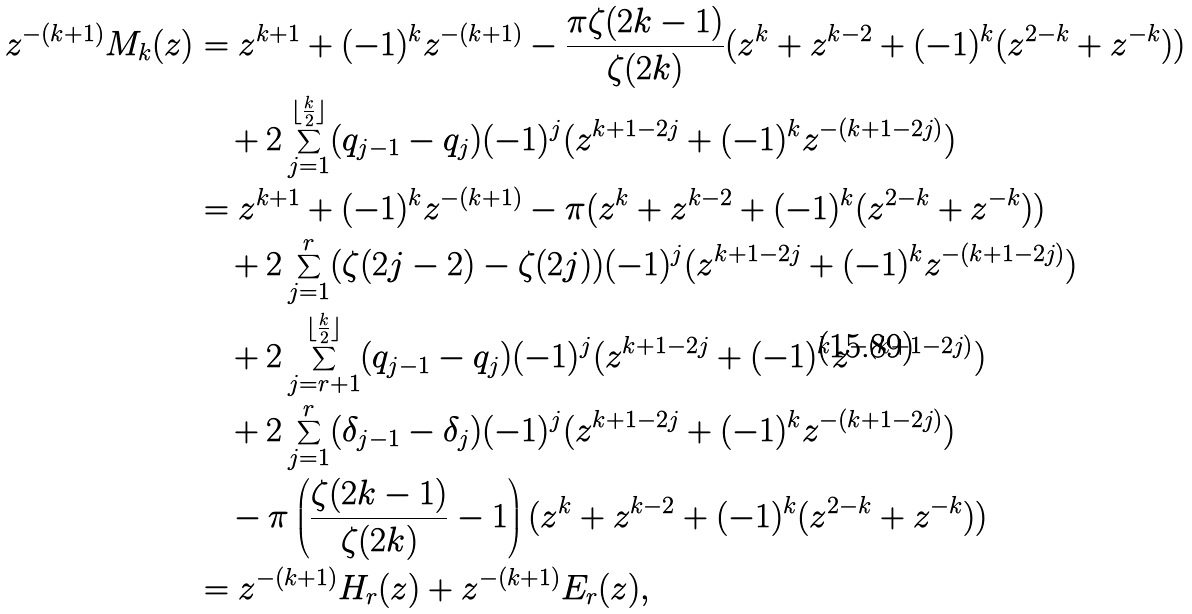<formula> <loc_0><loc_0><loc_500><loc_500>z ^ { - ( k + 1 ) } M _ { k } ( z ) & = z ^ { k + 1 } + ( - 1 ) ^ { k } z ^ { - ( k + 1 ) } - \frac { \pi \zeta ( 2 k - 1 ) } { \zeta ( 2 k ) } ( z ^ { k } + z ^ { k - 2 } + ( - 1 ) ^ { k } ( z ^ { 2 - k } + z ^ { - k } ) ) \\ & \quad + 2 \sum _ { j = 1 } ^ { { \lfloor \frac { k } { 2 } \rfloor } } ( q _ { j - 1 } - q _ { j } ) ( - 1 ) ^ { j } ( z ^ { k + 1 - 2 j } + ( - 1 ) ^ { k } z ^ { - ( k + 1 - 2 j ) } ) \\ & = z ^ { k + 1 } + ( - 1 ) ^ { k } z ^ { - ( k + 1 ) } - \pi ( z ^ { k } + z ^ { k - 2 } + ( - 1 ) ^ { k } ( z ^ { 2 - k } + z ^ { - k } ) ) \\ & \quad + 2 \sum _ { j = 1 } ^ { r } ( \zeta ( 2 j - 2 ) - \zeta ( 2 j ) ) ( - 1 ) ^ { j } ( z ^ { k + 1 - 2 j } + ( - 1 ) ^ { k } z ^ { - ( k + 1 - 2 j ) } ) \\ & \quad + 2 \sum _ { j = r + 1 } ^ { { \lfloor \frac { k } { 2 } \rfloor } } ( q _ { j - 1 } - q _ { j } ) ( - 1 ) ^ { j } ( z ^ { k + 1 - 2 j } + ( - 1 ) ^ { k } z ^ { - ( k + 1 - 2 j ) } ) \\ & \quad + 2 \sum _ { j = 1 } ^ { r } ( \delta _ { j - 1 } - \delta _ { j } ) ( - 1 ) ^ { j } ( z ^ { k + 1 - 2 j } + ( - 1 ) ^ { k } z ^ { - ( k + 1 - 2 j ) } ) \\ & \quad - \pi \left ( \frac { \zeta ( 2 k - 1 ) } { \zeta ( 2 k ) } - 1 \right ) ( z ^ { k } + z ^ { k - 2 } + ( - 1 ) ^ { k } ( z ^ { 2 - k } + z ^ { - k } ) ) \\ & = z ^ { - ( k + 1 ) } H _ { r } ( z ) + z ^ { - ( k + 1 ) } E _ { r } ( z ) ,</formula> 